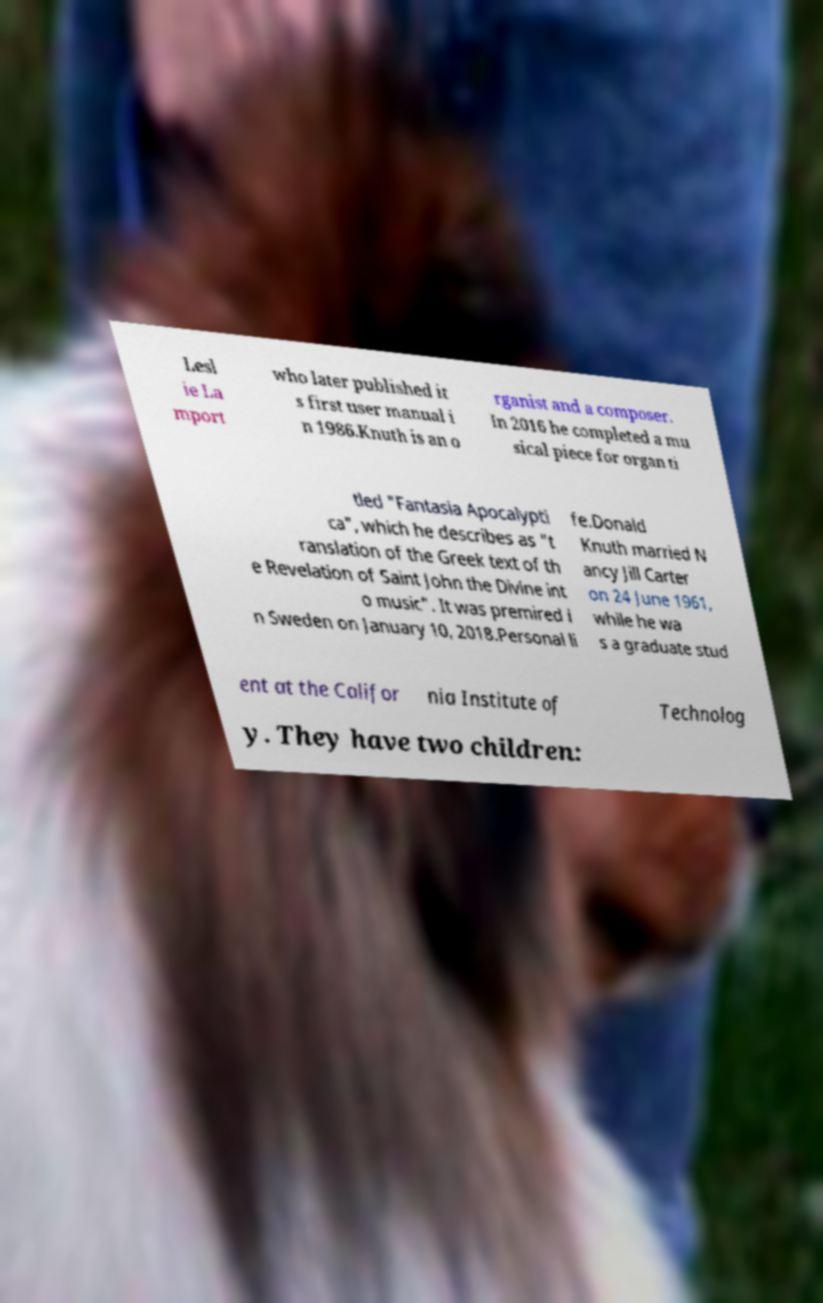Please read and relay the text visible in this image. What does it say? Lesl ie La mport who later published it s first user manual i n 1986.Knuth is an o rganist and a composer. In 2016 he completed a mu sical piece for organ ti tled "Fantasia Apocalypti ca", which he describes as "t ranslation of the Greek text of th e Revelation of Saint John the Divine int o music". It was premired i n Sweden on January 10, 2018.Personal li fe.Donald Knuth married N ancy Jill Carter on 24 June 1961, while he wa s a graduate stud ent at the Califor nia Institute of Technolog y. They have two children: 